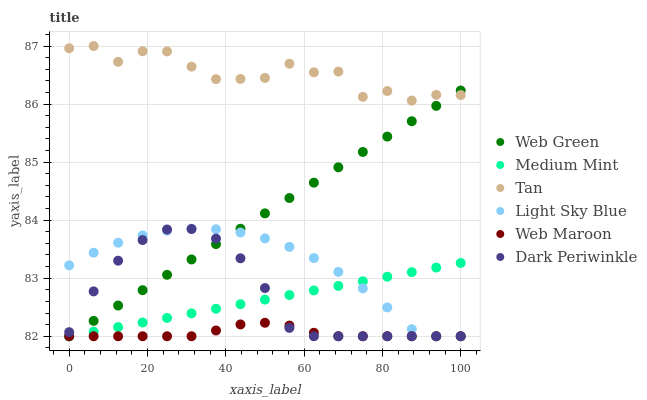Does Web Maroon have the minimum area under the curve?
Answer yes or no. Yes. Does Tan have the maximum area under the curve?
Answer yes or no. Yes. Does Web Green have the minimum area under the curve?
Answer yes or no. No. Does Web Green have the maximum area under the curve?
Answer yes or no. No. Is Medium Mint the smoothest?
Answer yes or no. Yes. Is Tan the roughest?
Answer yes or no. Yes. Is Web Maroon the smoothest?
Answer yes or no. No. Is Web Maroon the roughest?
Answer yes or no. No. Does Medium Mint have the lowest value?
Answer yes or no. Yes. Does Tan have the lowest value?
Answer yes or no. No. Does Tan have the highest value?
Answer yes or no. Yes. Does Web Green have the highest value?
Answer yes or no. No. Is Light Sky Blue less than Tan?
Answer yes or no. Yes. Is Tan greater than Web Maroon?
Answer yes or no. Yes. Does Dark Periwinkle intersect Web Green?
Answer yes or no. Yes. Is Dark Periwinkle less than Web Green?
Answer yes or no. No. Is Dark Periwinkle greater than Web Green?
Answer yes or no. No. Does Light Sky Blue intersect Tan?
Answer yes or no. No. 